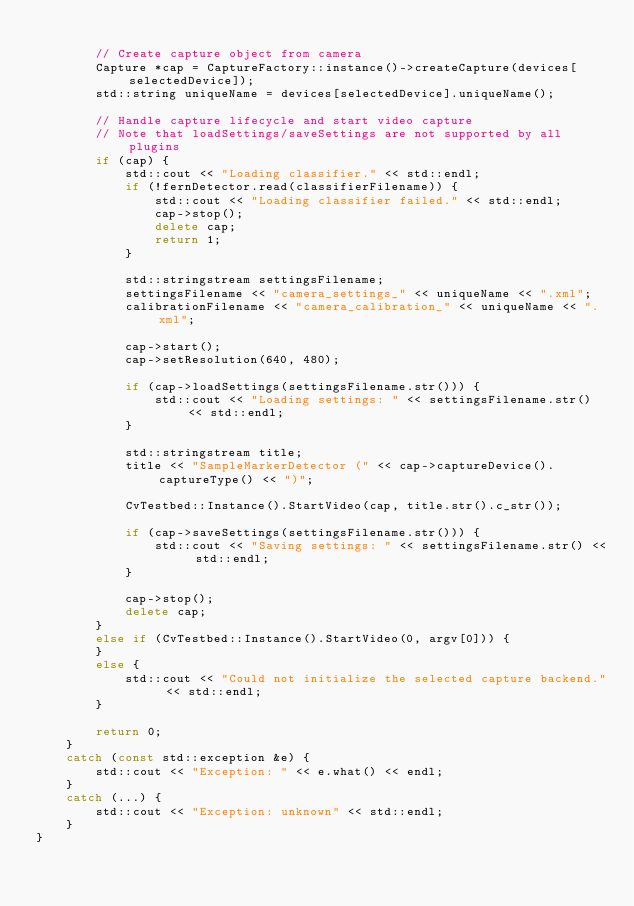Convert code to text. <code><loc_0><loc_0><loc_500><loc_500><_C++_>        
        // Create capture object from camera
        Capture *cap = CaptureFactory::instance()->createCapture(devices[selectedDevice]);
        std::string uniqueName = devices[selectedDevice].uniqueName();

        // Handle capture lifecycle and start video capture
        // Note that loadSettings/saveSettings are not supported by all plugins
        if (cap) {
            std::cout << "Loading classifier." << std::endl;
            if (!fernDetector.read(classifierFilename)) {
                std::cout << "Loading classifier failed." << std::endl;
                cap->stop();
                delete cap;
                return 1;
            }

            std::stringstream settingsFilename;
            settingsFilename << "camera_settings_" << uniqueName << ".xml";
            calibrationFilename << "camera_calibration_" << uniqueName << ".xml";
            
            cap->start();
            cap->setResolution(640, 480);
            
            if (cap->loadSettings(settingsFilename.str())) {
                std::cout << "Loading settings: " << settingsFilename.str() << std::endl;
            }

            std::stringstream title;
            title << "SampleMarkerDetector (" << cap->captureDevice().captureType() << ")";

            CvTestbed::Instance().StartVideo(cap, title.str().c_str());

            if (cap->saveSettings(settingsFilename.str())) {
                std::cout << "Saving settings: " << settingsFilename.str() << std::endl;
            }

            cap->stop();
            delete cap;
        }
        else if (CvTestbed::Instance().StartVideo(0, argv[0])) {
        }
        else {
            std::cout << "Could not initialize the selected capture backend." << std::endl;
        }

        return 0;
    }
    catch (const std::exception &e) {
        std::cout << "Exception: " << e.what() << endl;
    }
    catch (...) {
        std::cout << "Exception: unknown" << std::endl;
    }
}
</code> 